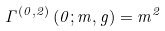<formula> <loc_0><loc_0><loc_500><loc_500>\Gamma ^ { ( 0 , 2 ) } \left ( 0 ; m , g \right ) = m ^ { 2 }</formula> 